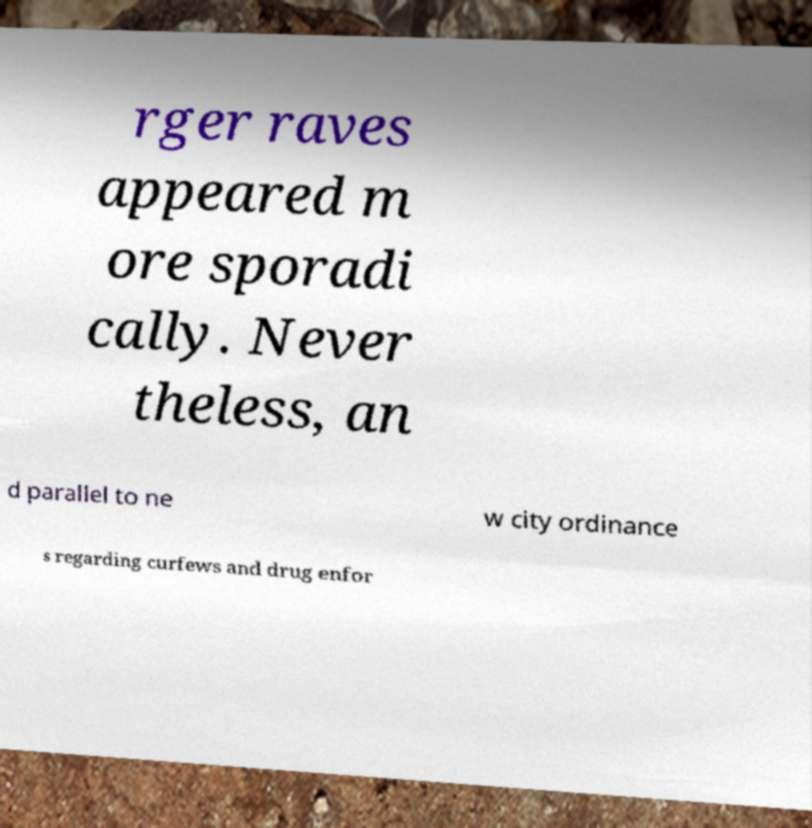There's text embedded in this image that I need extracted. Can you transcribe it verbatim? rger raves appeared m ore sporadi cally. Never theless, an d parallel to ne w city ordinance s regarding curfews and drug enfor 